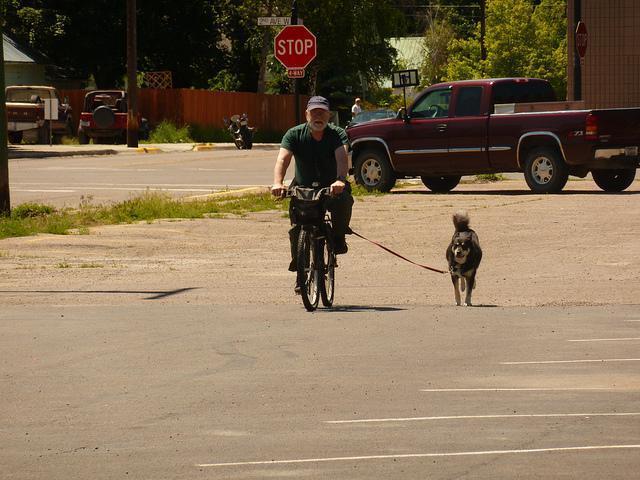How many people are visible in the picture?
Give a very brief answer. 1. How many dogs is the man walking?
Give a very brief answer. 1. How many trucks are visible?
Give a very brief answer. 2. 